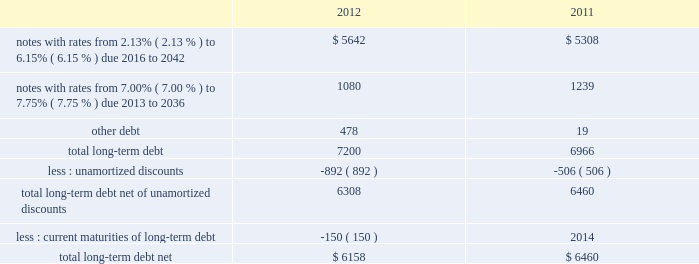Note 8 2013 debt our long-term debt consisted of the following ( in millions ) : .
In december 2012 , we issued notes totaling $ 1.3 billion with a fixed interest rate of 4.07% ( 4.07 % ) maturing in december 2042 ( the new notes ) in exchange for outstanding notes totaling $ 1.2 billion with interest rates ranging from 5.50% ( 5.50 % ) to 8.50% ( 8.50 % ) maturing in 2023 to 2040 ( the old notes ) .
In connection with the exchange , we paid a premium of $ 393 million , of which $ 225 million was paid in cash and $ 168 million was in the form of new notes .
This premium , in addition to $ 194 million in remaining unamortized discounts related to the old notes , will be amortized as additional interest expense over the term of the new notes using the effective interest method .
We may , at our option , redeem some or all of the new notes at any time by paying the principal amount of notes being redeemed plus a make-whole premium and accrued and unpaid interest .
Interest on the new notes is payable on june 15 and december 15 of each year , beginning on june 15 , 2013 .
The new notes are unsecured senior obligations and rank equally in right of payment with all of our existing and future unsecured and unsubordinated indebtedness .
On september 9 , 2011 , we issued $ 2.0 billion of long-term notes in a registered public offering consisting of $ 500 million maturing in 2016 with a fixed interest rate of 2.13% ( 2.13 % ) , $ 900 million maturing in 2021 with a fixed interest rate of 3.35% ( 3.35 % ) , and $ 600 million maturing in 2041 with a fixed interest rate of 4.85% ( 4.85 % ) .
We may , at our option , redeem some or all of the notes at any time by paying the principal amount of notes being redeemed plus a make-whole premium and accrued and unpaid interest .
Interest on the notes is payable on march 15 and september 15 of each year , beginning on march 15 , 2012 .
In october 2011 , we used a portion of the proceeds to redeem all of our $ 500 million long-term notes maturing in 2013 .
In 2011 , we repurchased $ 84 million of our long-term notes through open-market purchases .
We paid premiums of $ 48 million in connection with the early extinguishments of debt , which were recognized in other non-operating income ( expense ) , net .
In august 2011 , we entered into a $ 1.5 billion revolving credit facility with a group of banks and terminated our existing $ 1.5 billion revolving credit facility that was to expire in june 2012 .
The credit facility expires august 2016 , and we may request and the banks may grant , at their discretion , an increase to the credit facility by an additional amount up to $ 500 million .
There were no borrowings outstanding under either facility through december 31 , 2012 .
Borrowings under the credit facility would be unsecured and bear interest at rates based , at our option , on a eurodollar rate or a base rate , as defined in the credit facility .
Each bank 2019s obligation to make loans under the credit facility is subject to , among other things , our compliance with various representations , warranties and covenants , including covenants limiting our ability and certain of our subsidiaries 2019 ability to encumber assets and a covenant not to exceed a maximum leverage ratio , as defined in the credit facility .
The leverage ratio covenant excludes the adjustments recognized in stockholders 2019 equity related to postretirement benefit plans .
As of december 31 , 2012 , we were in compliance with all covenants contained in the credit facility , as well as in our debt agreements .
We have agreements in place with banking institutions to provide for the issuance of commercial paper .
There were no commercial paper borrowings outstanding during 2012 or 2011 .
If we were to issue commercial paper , the borrowings would be supported by the credit facility .
During the next five years , we have scheduled long-term debt maturities of $ 150 million due in 2013 and $ 952 million due in 2016 .
Interest payments were $ 378 million in 2012 , $ 326 million in 2011 , and $ 337 million in 2010. .
In 2012 what was the percentage of the premium apid to the exchange for outstanding notes exchanged? 
Computations: (393 / 1.2)
Answer: 327.5. 